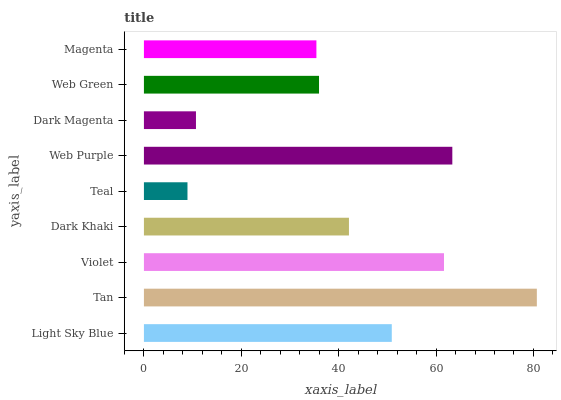Is Teal the minimum?
Answer yes or no. Yes. Is Tan the maximum?
Answer yes or no. Yes. Is Violet the minimum?
Answer yes or no. No. Is Violet the maximum?
Answer yes or no. No. Is Tan greater than Violet?
Answer yes or no. Yes. Is Violet less than Tan?
Answer yes or no. Yes. Is Violet greater than Tan?
Answer yes or no. No. Is Tan less than Violet?
Answer yes or no. No. Is Dark Khaki the high median?
Answer yes or no. Yes. Is Dark Khaki the low median?
Answer yes or no. Yes. Is Web Purple the high median?
Answer yes or no. No. Is Violet the low median?
Answer yes or no. No. 